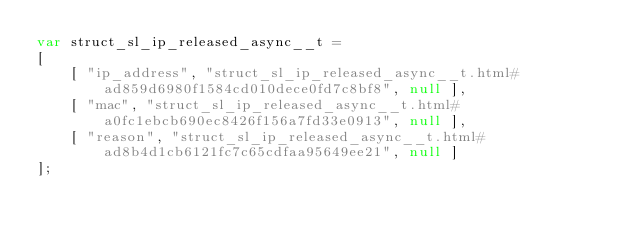Convert code to text. <code><loc_0><loc_0><loc_500><loc_500><_JavaScript_>var struct_sl_ip_released_async__t =
[
    [ "ip_address", "struct_sl_ip_released_async__t.html#ad859d6980f1584cd010dece0fd7c8bf8", null ],
    [ "mac", "struct_sl_ip_released_async__t.html#a0fc1ebcb690ec8426f156a7fd33e0913", null ],
    [ "reason", "struct_sl_ip_released_async__t.html#ad8b4d1cb6121fc7c65cdfaa95649ee21", null ]
];</code> 